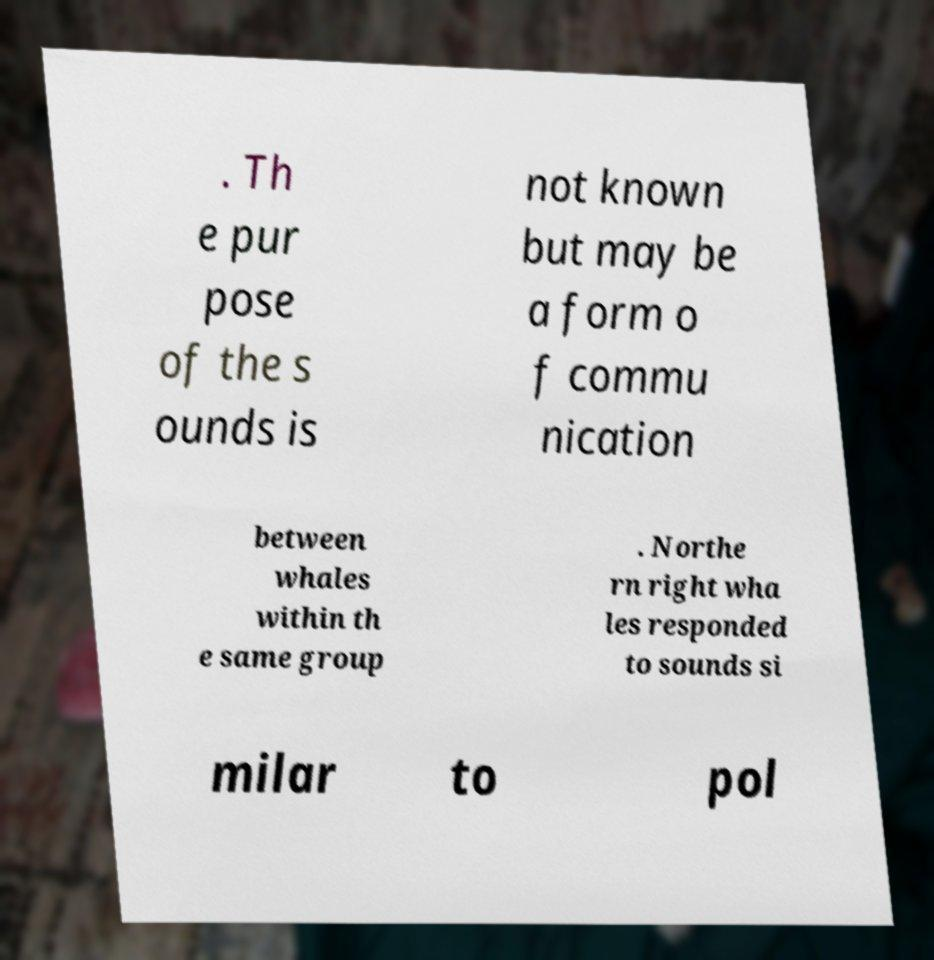Please read and relay the text visible in this image. What does it say? . Th e pur pose of the s ounds is not known but may be a form o f commu nication between whales within th e same group . Northe rn right wha les responded to sounds si milar to pol 